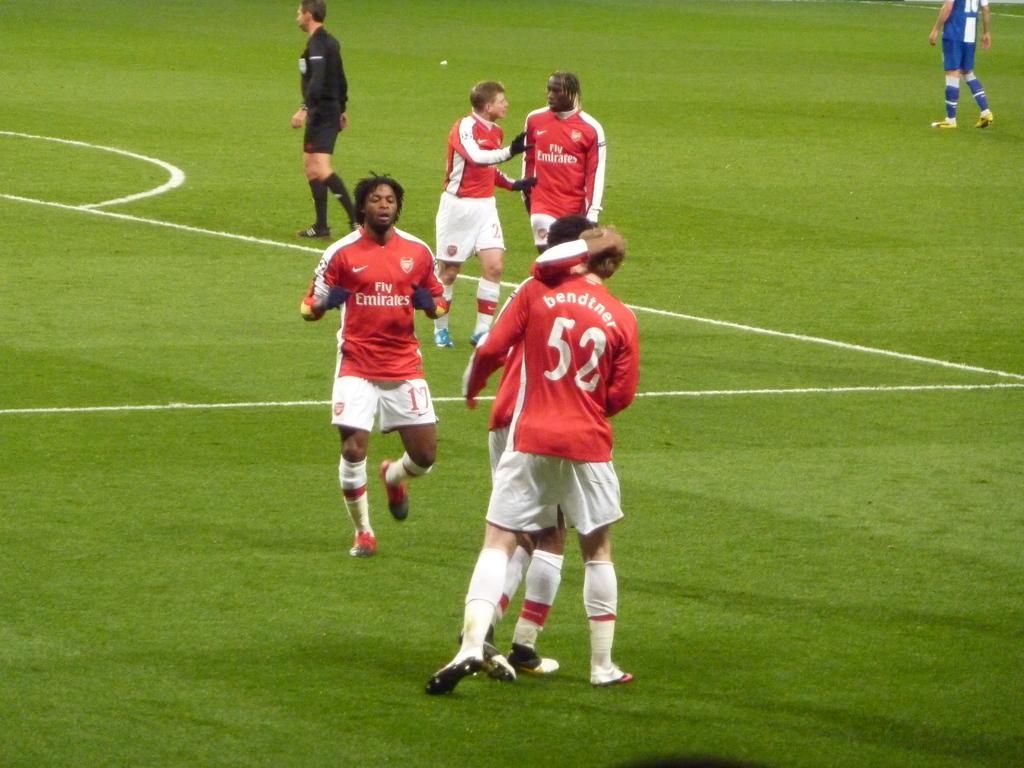What number is on the back of the jersey?
Provide a succinct answer. 52. What does the front of the shirt say?
Your answer should be compact. Fly emirates. 